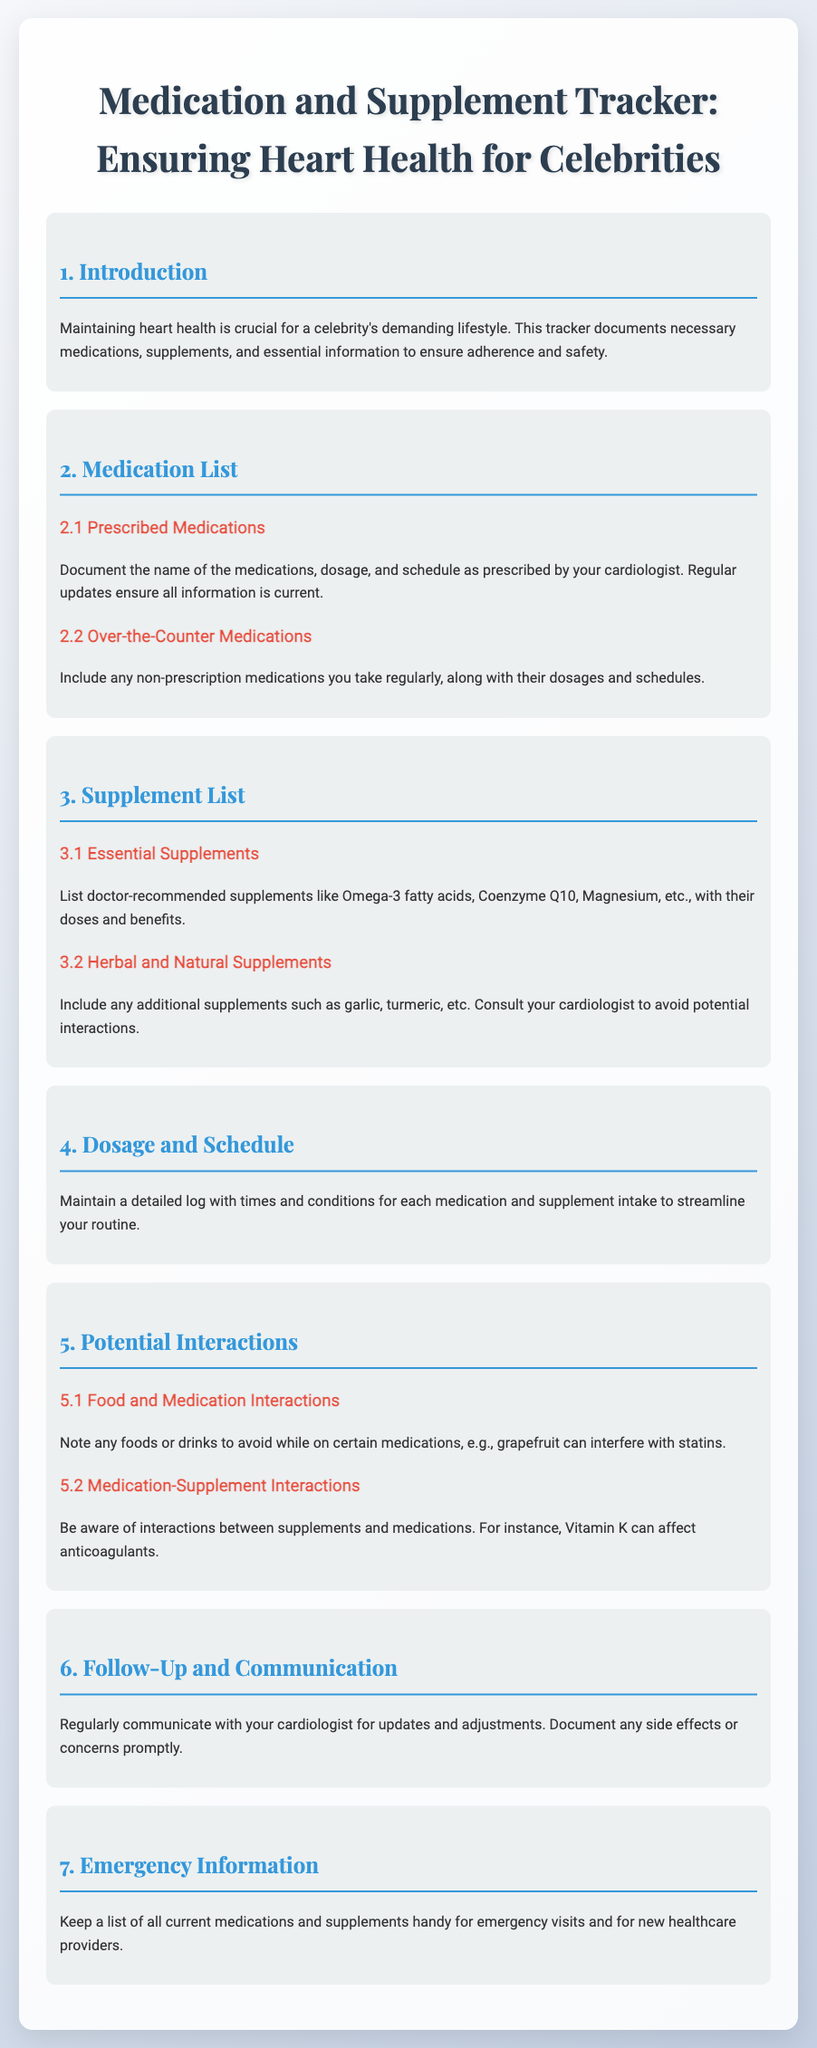What is the purpose of the tracker? The purpose of the tracker is to document necessary medications and supplements to ensure adherence and safety for heart health.
Answer: To ensure adherence and safety What should be included in the prescribed medications section? The prescribed medications section should include the name of the medications, dosage, and schedule as prescribed by the cardiologist.
Answer: Medication name, dosage, schedule What are some examples of essential supplements mentioned? Essential supplements mentioned include Omega-3 fatty acids, Coenzyme Q10, and Magnesium.
Answer: Omega-3 fatty acids, Coenzyme Q10, Magnesium What food should be avoided with certain medications? Grapefruit should be avoided while on certain medications, as it can interfere with statins.
Answer: Grapefruit Why is communication with the cardiologist important? Communication with the cardiologist is important for updates and adjustments, and to document any side effects or concerns.
Answer: For updates and adjustments What should you keep handy for emergency visits? You should keep a list of all current medications and supplements handy for emergency visits.
Answer: Current medications and supplements list What does the tracker document? The tracker documents prescribed medications, supplements, dosages, schedules, and potential interactions.
Answer: Medications, supplements, dosages, schedules, interactions 